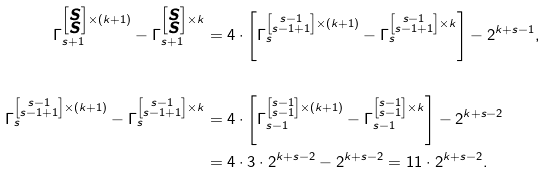<formula> <loc_0><loc_0><loc_500><loc_500>\Gamma _ { s + 1 } ^ { \left [ \substack { s \\ s } \right ] \times ( k + 1 ) } - \Gamma _ { s + 1 } ^ { \left [ \substack { s \\ s } \right ] \times k } & = 4 \cdot \left [ \Gamma _ { s } ^ { \left [ \substack { s - 1 \\ s - 1 + 1 } \right ] \times ( k + 1 ) } - \Gamma _ { s } ^ { \left [ \substack { s - 1 \\ s - 1 + 1 } \right ] \times k } \right ] - 2 ^ { k + s - 1 } , \\ & \\ \Gamma _ { s } ^ { \left [ \substack { s - 1 \\ s - 1 + 1 } \right ] \times ( k + 1 ) } - \Gamma _ { s } ^ { \left [ \substack { s - 1 \\ s - 1 + 1 } \right ] \times k } & = 4 \cdot \left [ \Gamma _ { s - 1 } ^ { \left [ \substack { s - 1 \\ s - 1 } \right ] \times ( k + 1 ) } - \Gamma _ { s - 1 } ^ { \left [ \substack { s - 1 \\ s - 1 } \right ] \times k } \right ] - 2 ^ { k + s - 2 } \\ & = 4 \cdot 3 \cdot 2 ^ { k + s - 2 } - 2 ^ { k + s - 2 } = 1 1 \cdot 2 ^ { k + s - 2 } .</formula> 